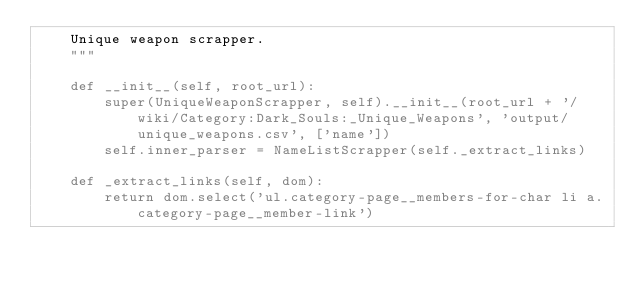Convert code to text. <code><loc_0><loc_0><loc_500><loc_500><_Python_>    Unique weapon scrapper.
    """

    def __init__(self, root_url):
        super(UniqueWeaponScrapper, self).__init__(root_url + '/wiki/Category:Dark_Souls:_Unique_Weapons', 'output/unique_weapons.csv', ['name'])
        self.inner_parser = NameListScrapper(self._extract_links)

    def _extract_links(self, dom):
        return dom.select('ul.category-page__members-for-char li a.category-page__member-link')</code> 